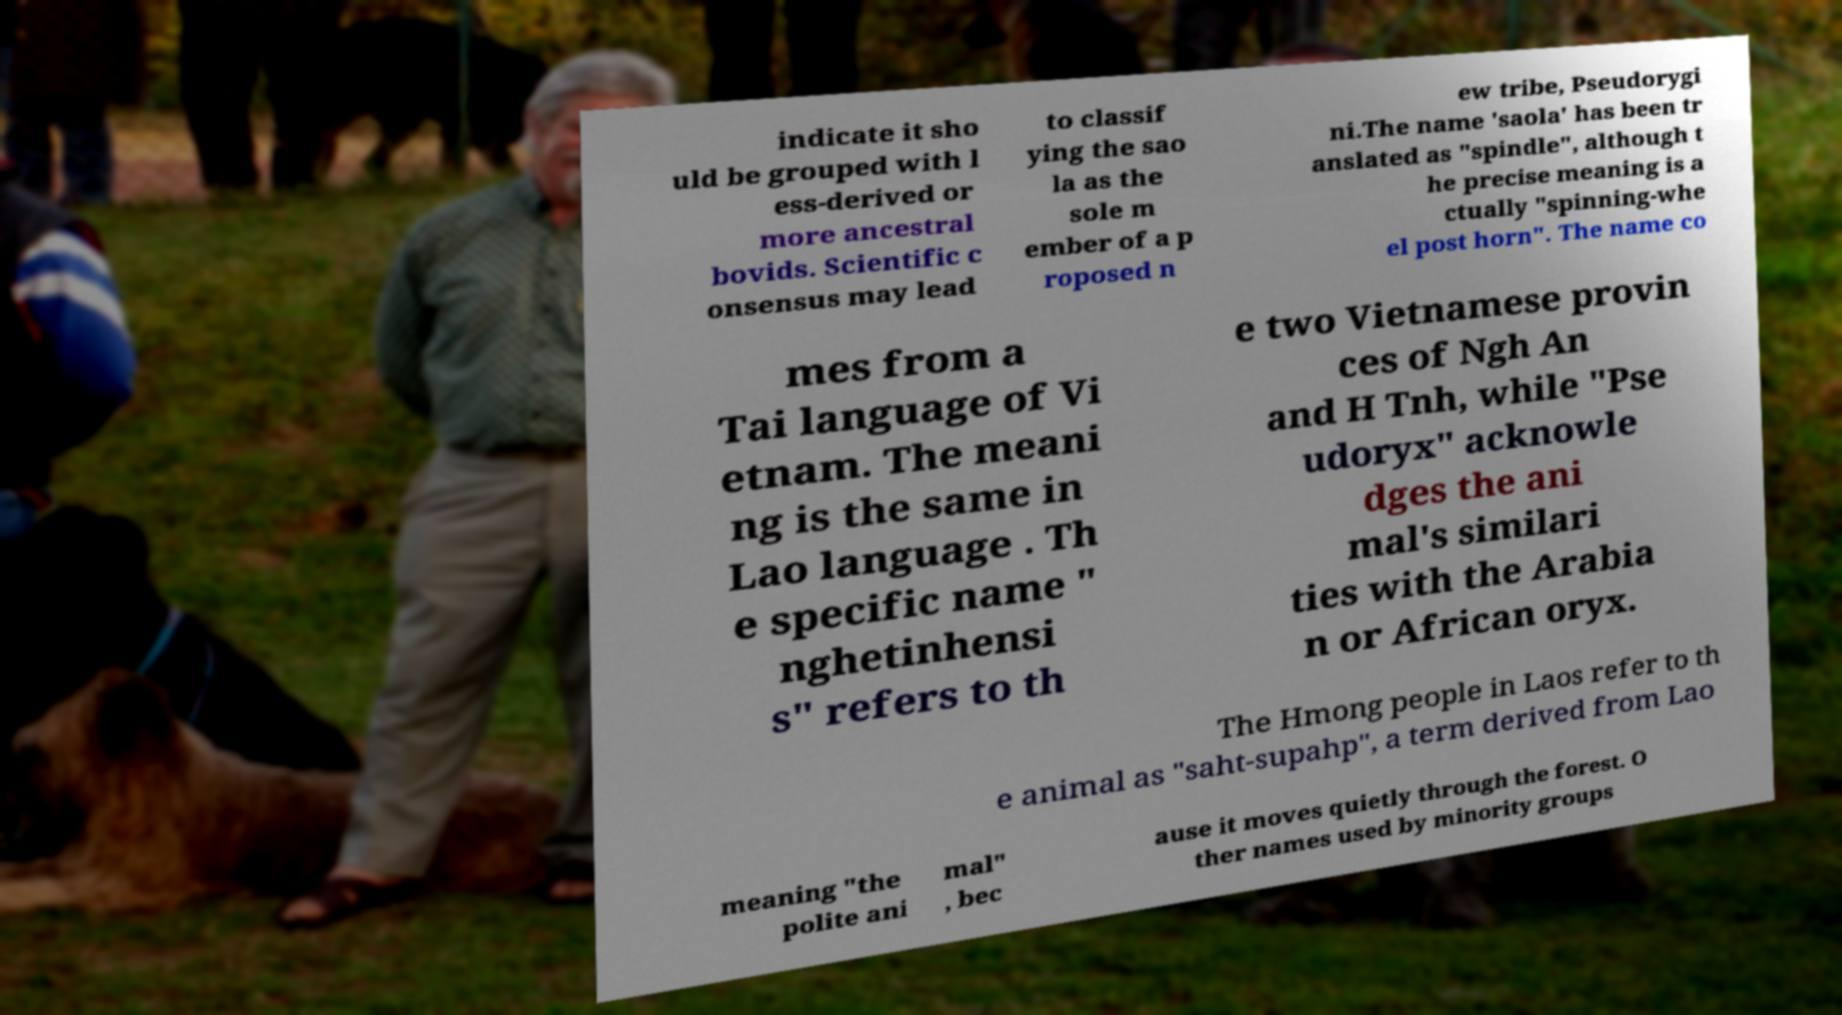Can you read and provide the text displayed in the image?This photo seems to have some interesting text. Can you extract and type it out for me? indicate it sho uld be grouped with l ess-derived or more ancestral bovids. Scientific c onsensus may lead to classif ying the sao la as the sole m ember of a p roposed n ew tribe, Pseudorygi ni.The name 'saola' has been tr anslated as "spindle", although t he precise meaning is a ctually "spinning-whe el post horn". The name co mes from a Tai language of Vi etnam. The meani ng is the same in Lao language . Th e specific name " nghetinhensi s" refers to th e two Vietnamese provin ces of Ngh An and H Tnh, while "Pse udoryx" acknowle dges the ani mal's similari ties with the Arabia n or African oryx. The Hmong people in Laos refer to th e animal as "saht-supahp", a term derived from Lao meaning "the polite ani mal" , bec ause it moves quietly through the forest. O ther names used by minority groups 